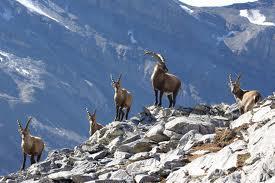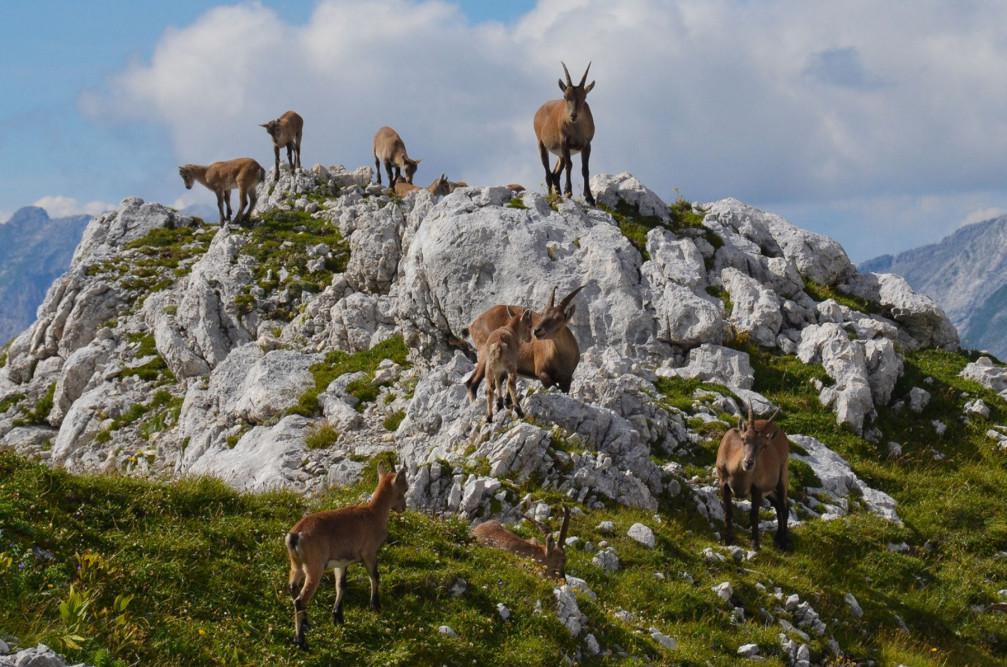The first image is the image on the left, the second image is the image on the right. Examine the images to the left and right. Is the description "An image includes a rearing horned animal with front legs raised, facing off with another horned animal." accurate? Answer yes or no. No. The first image is the image on the left, the second image is the image on the right. For the images displayed, is the sentence "Three horned animals are in a grassy area in the image on the right." factually correct? Answer yes or no. No. 